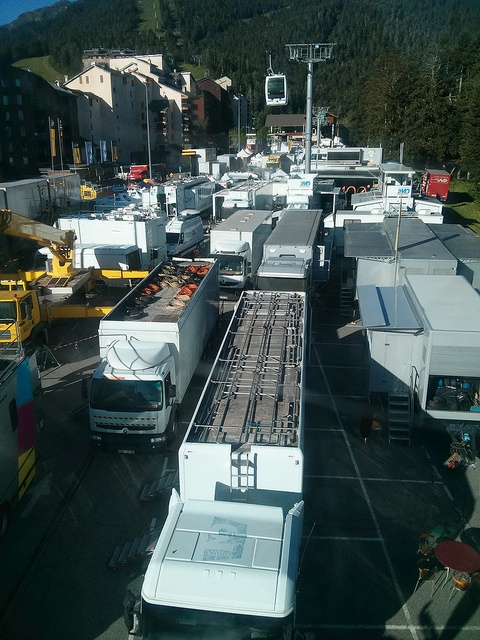Describe the objects in this image and their specific colors. I can see truck in teal, lightblue, black, darkgray, and gray tones, truck in teal, black, gray, lightgray, and purple tones, truck in teal, gray, black, and darkgray tones, truck in teal, darkgray, lightgray, gray, and black tones, and dining table in teal, black, maroon, and gray tones in this image. 